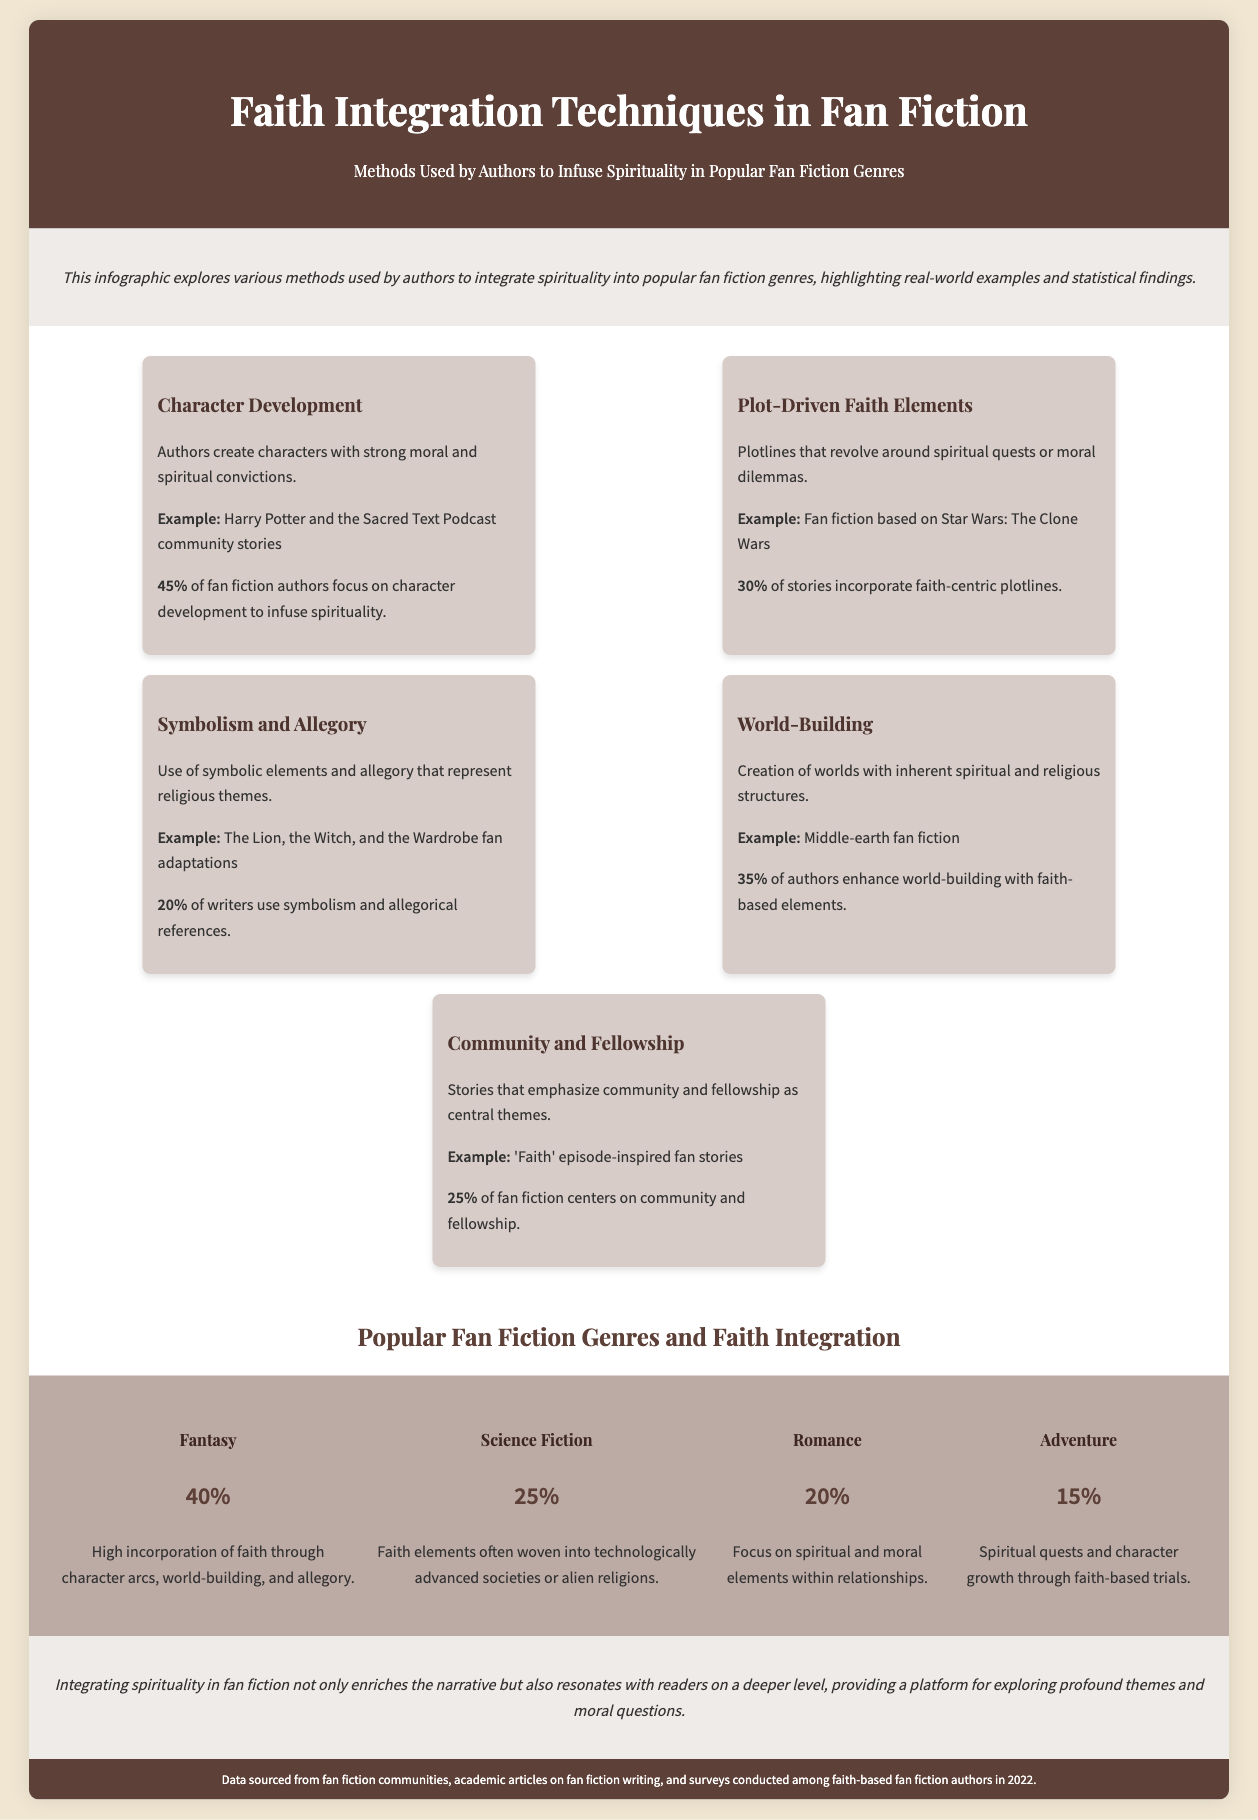what percentage of fan fiction authors focus on character development? The document states that 45% of fan fiction authors focus on character development to infuse spirituality.
Answer: 45% what is one example of a plot-driven faith element? The document provides "Fan fiction based on Star Wars: The Clone Wars" as an example of plot-driven faith elements.
Answer: Star Wars: The Clone Wars which technique has the lowest percentage of use among authors? The document mentions that 20% of writers use symbolism and allegorical references, which is the lowest percentage compared to other techniques.
Answer: 20% how many popular fan fiction genres are listed in the document? The document lists four popular fan fiction genres: Fantasy, Science Fiction, Romance, and Adventure.
Answer: Four which genre has the highest incorporation of faith elements? The document states that Fantasy has the highest incorporation of faith elements at 40%.
Answer: Fantasy what method is used by 25% of fan fiction authors in their stories? The document notes that community and fellowship are emphasized by 25% of fan fiction authors in their stories.
Answer: Community and fellowship what example is given for world-building with faith-based elements? The document highlights "Middle-earth fan fiction" as an example of enhancing world-building with faith-based elements.
Answer: Middle-earth fan fiction what themes are often explored in romance fan fiction? The document indicates that romance fan fiction focuses on spiritual and moral elements within relationships.
Answer: Spiritual and moral elements in which year were the data sources for the document collected? The footnote mentions that the data was sourced from surveys conducted among faith-based fan fiction authors in 2022.
Answer: 2022 